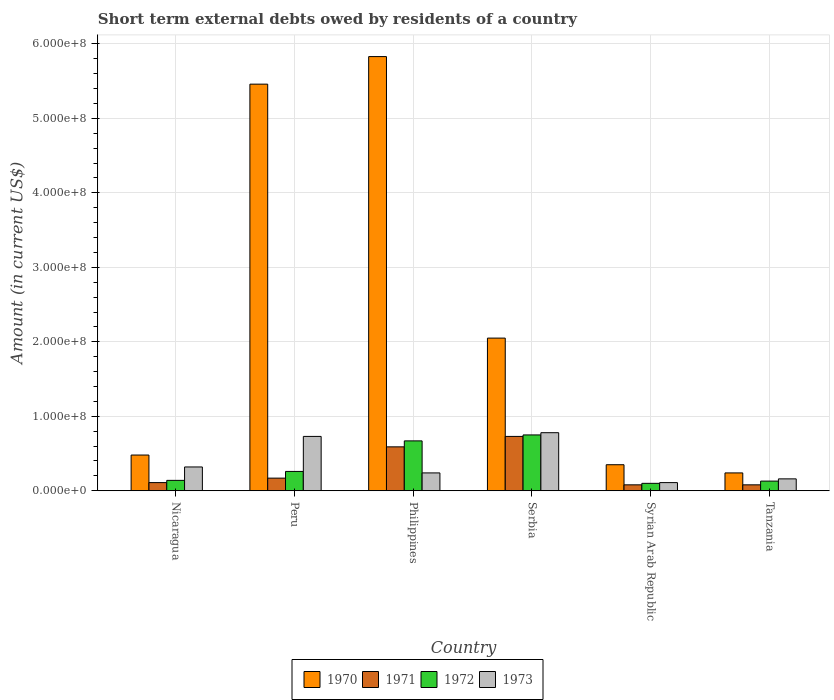How many different coloured bars are there?
Make the answer very short. 4. Are the number of bars on each tick of the X-axis equal?
Make the answer very short. Yes. How many bars are there on the 6th tick from the left?
Offer a terse response. 4. How many bars are there on the 5th tick from the right?
Provide a short and direct response. 4. What is the amount of short-term external debts owed by residents in 1972 in Serbia?
Your answer should be very brief. 7.50e+07. Across all countries, what is the maximum amount of short-term external debts owed by residents in 1971?
Make the answer very short. 7.30e+07. Across all countries, what is the minimum amount of short-term external debts owed by residents in 1972?
Give a very brief answer. 1.00e+07. In which country was the amount of short-term external debts owed by residents in 1973 maximum?
Ensure brevity in your answer.  Serbia. In which country was the amount of short-term external debts owed by residents in 1972 minimum?
Make the answer very short. Syrian Arab Republic. What is the total amount of short-term external debts owed by residents in 1971 in the graph?
Your answer should be compact. 1.76e+08. What is the difference between the amount of short-term external debts owed by residents in 1971 in Peru and that in Philippines?
Provide a succinct answer. -4.20e+07. What is the difference between the amount of short-term external debts owed by residents in 1970 in Peru and the amount of short-term external debts owed by residents in 1971 in Nicaragua?
Your answer should be very brief. 5.35e+08. What is the average amount of short-term external debts owed by residents in 1972 per country?
Make the answer very short. 3.42e+07. What is the difference between the amount of short-term external debts owed by residents of/in 1973 and amount of short-term external debts owed by residents of/in 1970 in Tanzania?
Keep it short and to the point. -8.00e+06. In how many countries, is the amount of short-term external debts owed by residents in 1970 greater than 400000000 US$?
Your answer should be compact. 2. What is the ratio of the amount of short-term external debts owed by residents in 1970 in Nicaragua to that in Philippines?
Give a very brief answer. 0.08. Is the amount of short-term external debts owed by residents in 1973 in Peru less than that in Syrian Arab Republic?
Provide a short and direct response. No. What is the difference between the highest and the second highest amount of short-term external debts owed by residents in 1971?
Provide a short and direct response. 5.60e+07. What is the difference between the highest and the lowest amount of short-term external debts owed by residents in 1972?
Your response must be concise. 6.50e+07. In how many countries, is the amount of short-term external debts owed by residents in 1972 greater than the average amount of short-term external debts owed by residents in 1972 taken over all countries?
Offer a terse response. 2. Is it the case that in every country, the sum of the amount of short-term external debts owed by residents in 1971 and amount of short-term external debts owed by residents in 1972 is greater than the sum of amount of short-term external debts owed by residents in 1970 and amount of short-term external debts owed by residents in 1973?
Give a very brief answer. No. What does the 3rd bar from the right in Nicaragua represents?
Ensure brevity in your answer.  1971. Is it the case that in every country, the sum of the amount of short-term external debts owed by residents in 1970 and amount of short-term external debts owed by residents in 1971 is greater than the amount of short-term external debts owed by residents in 1973?
Your answer should be very brief. Yes. How many bars are there?
Your response must be concise. 24. How many countries are there in the graph?
Provide a short and direct response. 6. Are the values on the major ticks of Y-axis written in scientific E-notation?
Your response must be concise. Yes. Does the graph contain any zero values?
Give a very brief answer. No. Does the graph contain grids?
Your response must be concise. Yes. Where does the legend appear in the graph?
Keep it short and to the point. Bottom center. How many legend labels are there?
Keep it short and to the point. 4. How are the legend labels stacked?
Provide a succinct answer. Horizontal. What is the title of the graph?
Your answer should be compact. Short term external debts owed by residents of a country. What is the label or title of the X-axis?
Ensure brevity in your answer.  Country. What is the label or title of the Y-axis?
Keep it short and to the point. Amount (in current US$). What is the Amount (in current US$) of 1970 in Nicaragua?
Keep it short and to the point. 4.80e+07. What is the Amount (in current US$) in 1971 in Nicaragua?
Give a very brief answer. 1.10e+07. What is the Amount (in current US$) in 1972 in Nicaragua?
Your answer should be very brief. 1.40e+07. What is the Amount (in current US$) of 1973 in Nicaragua?
Your answer should be compact. 3.20e+07. What is the Amount (in current US$) in 1970 in Peru?
Ensure brevity in your answer.  5.46e+08. What is the Amount (in current US$) in 1971 in Peru?
Give a very brief answer. 1.70e+07. What is the Amount (in current US$) in 1972 in Peru?
Your answer should be compact. 2.60e+07. What is the Amount (in current US$) of 1973 in Peru?
Offer a very short reply. 7.30e+07. What is the Amount (in current US$) in 1970 in Philippines?
Provide a succinct answer. 5.83e+08. What is the Amount (in current US$) in 1971 in Philippines?
Your answer should be very brief. 5.90e+07. What is the Amount (in current US$) of 1972 in Philippines?
Your answer should be compact. 6.70e+07. What is the Amount (in current US$) of 1973 in Philippines?
Ensure brevity in your answer.  2.40e+07. What is the Amount (in current US$) in 1970 in Serbia?
Provide a succinct answer. 2.05e+08. What is the Amount (in current US$) in 1971 in Serbia?
Your answer should be compact. 7.30e+07. What is the Amount (in current US$) in 1972 in Serbia?
Provide a succinct answer. 7.50e+07. What is the Amount (in current US$) of 1973 in Serbia?
Your response must be concise. 7.80e+07. What is the Amount (in current US$) of 1970 in Syrian Arab Republic?
Ensure brevity in your answer.  3.50e+07. What is the Amount (in current US$) in 1973 in Syrian Arab Republic?
Your answer should be compact. 1.10e+07. What is the Amount (in current US$) in 1970 in Tanzania?
Provide a short and direct response. 2.40e+07. What is the Amount (in current US$) in 1972 in Tanzania?
Your answer should be compact. 1.30e+07. What is the Amount (in current US$) in 1973 in Tanzania?
Offer a very short reply. 1.60e+07. Across all countries, what is the maximum Amount (in current US$) in 1970?
Offer a terse response. 5.83e+08. Across all countries, what is the maximum Amount (in current US$) of 1971?
Keep it short and to the point. 7.30e+07. Across all countries, what is the maximum Amount (in current US$) in 1972?
Your answer should be compact. 7.50e+07. Across all countries, what is the maximum Amount (in current US$) of 1973?
Provide a short and direct response. 7.80e+07. Across all countries, what is the minimum Amount (in current US$) of 1970?
Your answer should be very brief. 2.40e+07. Across all countries, what is the minimum Amount (in current US$) in 1973?
Keep it short and to the point. 1.10e+07. What is the total Amount (in current US$) in 1970 in the graph?
Offer a very short reply. 1.44e+09. What is the total Amount (in current US$) in 1971 in the graph?
Make the answer very short. 1.76e+08. What is the total Amount (in current US$) in 1972 in the graph?
Offer a very short reply. 2.05e+08. What is the total Amount (in current US$) in 1973 in the graph?
Your answer should be compact. 2.34e+08. What is the difference between the Amount (in current US$) of 1970 in Nicaragua and that in Peru?
Offer a very short reply. -4.98e+08. What is the difference between the Amount (in current US$) in 1971 in Nicaragua and that in Peru?
Ensure brevity in your answer.  -6.00e+06. What is the difference between the Amount (in current US$) of 1972 in Nicaragua and that in Peru?
Your answer should be compact. -1.20e+07. What is the difference between the Amount (in current US$) of 1973 in Nicaragua and that in Peru?
Offer a very short reply. -4.10e+07. What is the difference between the Amount (in current US$) in 1970 in Nicaragua and that in Philippines?
Your answer should be compact. -5.35e+08. What is the difference between the Amount (in current US$) of 1971 in Nicaragua and that in Philippines?
Your response must be concise. -4.80e+07. What is the difference between the Amount (in current US$) of 1972 in Nicaragua and that in Philippines?
Provide a short and direct response. -5.30e+07. What is the difference between the Amount (in current US$) in 1970 in Nicaragua and that in Serbia?
Ensure brevity in your answer.  -1.57e+08. What is the difference between the Amount (in current US$) of 1971 in Nicaragua and that in Serbia?
Offer a terse response. -6.20e+07. What is the difference between the Amount (in current US$) of 1972 in Nicaragua and that in Serbia?
Offer a very short reply. -6.10e+07. What is the difference between the Amount (in current US$) in 1973 in Nicaragua and that in Serbia?
Your answer should be very brief. -4.60e+07. What is the difference between the Amount (in current US$) in 1970 in Nicaragua and that in Syrian Arab Republic?
Offer a terse response. 1.30e+07. What is the difference between the Amount (in current US$) of 1971 in Nicaragua and that in Syrian Arab Republic?
Keep it short and to the point. 3.00e+06. What is the difference between the Amount (in current US$) of 1972 in Nicaragua and that in Syrian Arab Republic?
Ensure brevity in your answer.  4.00e+06. What is the difference between the Amount (in current US$) in 1973 in Nicaragua and that in Syrian Arab Republic?
Offer a terse response. 2.10e+07. What is the difference between the Amount (in current US$) of 1970 in Nicaragua and that in Tanzania?
Offer a very short reply. 2.40e+07. What is the difference between the Amount (in current US$) of 1971 in Nicaragua and that in Tanzania?
Offer a terse response. 3.00e+06. What is the difference between the Amount (in current US$) in 1973 in Nicaragua and that in Tanzania?
Your answer should be compact. 1.60e+07. What is the difference between the Amount (in current US$) in 1970 in Peru and that in Philippines?
Ensure brevity in your answer.  -3.70e+07. What is the difference between the Amount (in current US$) of 1971 in Peru and that in Philippines?
Make the answer very short. -4.20e+07. What is the difference between the Amount (in current US$) of 1972 in Peru and that in Philippines?
Make the answer very short. -4.10e+07. What is the difference between the Amount (in current US$) in 1973 in Peru and that in Philippines?
Make the answer very short. 4.90e+07. What is the difference between the Amount (in current US$) of 1970 in Peru and that in Serbia?
Offer a terse response. 3.41e+08. What is the difference between the Amount (in current US$) in 1971 in Peru and that in Serbia?
Ensure brevity in your answer.  -5.60e+07. What is the difference between the Amount (in current US$) in 1972 in Peru and that in Serbia?
Provide a short and direct response. -4.90e+07. What is the difference between the Amount (in current US$) in 1973 in Peru and that in Serbia?
Your answer should be compact. -5.00e+06. What is the difference between the Amount (in current US$) of 1970 in Peru and that in Syrian Arab Republic?
Offer a very short reply. 5.11e+08. What is the difference between the Amount (in current US$) of 1971 in Peru and that in Syrian Arab Republic?
Provide a succinct answer. 9.00e+06. What is the difference between the Amount (in current US$) in 1972 in Peru and that in Syrian Arab Republic?
Ensure brevity in your answer.  1.60e+07. What is the difference between the Amount (in current US$) in 1973 in Peru and that in Syrian Arab Republic?
Your response must be concise. 6.20e+07. What is the difference between the Amount (in current US$) in 1970 in Peru and that in Tanzania?
Make the answer very short. 5.22e+08. What is the difference between the Amount (in current US$) of 1971 in Peru and that in Tanzania?
Your answer should be compact. 9.00e+06. What is the difference between the Amount (in current US$) in 1972 in Peru and that in Tanzania?
Offer a terse response. 1.30e+07. What is the difference between the Amount (in current US$) in 1973 in Peru and that in Tanzania?
Ensure brevity in your answer.  5.70e+07. What is the difference between the Amount (in current US$) of 1970 in Philippines and that in Serbia?
Offer a terse response. 3.78e+08. What is the difference between the Amount (in current US$) of 1971 in Philippines and that in Serbia?
Offer a very short reply. -1.40e+07. What is the difference between the Amount (in current US$) of 1972 in Philippines and that in Serbia?
Offer a very short reply. -8.00e+06. What is the difference between the Amount (in current US$) of 1973 in Philippines and that in Serbia?
Your answer should be compact. -5.40e+07. What is the difference between the Amount (in current US$) of 1970 in Philippines and that in Syrian Arab Republic?
Provide a short and direct response. 5.48e+08. What is the difference between the Amount (in current US$) of 1971 in Philippines and that in Syrian Arab Republic?
Make the answer very short. 5.10e+07. What is the difference between the Amount (in current US$) of 1972 in Philippines and that in Syrian Arab Republic?
Your answer should be very brief. 5.70e+07. What is the difference between the Amount (in current US$) of 1973 in Philippines and that in Syrian Arab Republic?
Give a very brief answer. 1.30e+07. What is the difference between the Amount (in current US$) of 1970 in Philippines and that in Tanzania?
Your answer should be compact. 5.59e+08. What is the difference between the Amount (in current US$) in 1971 in Philippines and that in Tanzania?
Your response must be concise. 5.10e+07. What is the difference between the Amount (in current US$) in 1972 in Philippines and that in Tanzania?
Offer a very short reply. 5.40e+07. What is the difference between the Amount (in current US$) of 1970 in Serbia and that in Syrian Arab Republic?
Your answer should be very brief. 1.70e+08. What is the difference between the Amount (in current US$) in 1971 in Serbia and that in Syrian Arab Republic?
Keep it short and to the point. 6.50e+07. What is the difference between the Amount (in current US$) in 1972 in Serbia and that in Syrian Arab Republic?
Keep it short and to the point. 6.50e+07. What is the difference between the Amount (in current US$) in 1973 in Serbia and that in Syrian Arab Republic?
Provide a short and direct response. 6.70e+07. What is the difference between the Amount (in current US$) in 1970 in Serbia and that in Tanzania?
Keep it short and to the point. 1.81e+08. What is the difference between the Amount (in current US$) in 1971 in Serbia and that in Tanzania?
Your response must be concise. 6.50e+07. What is the difference between the Amount (in current US$) of 1972 in Serbia and that in Tanzania?
Provide a succinct answer. 6.20e+07. What is the difference between the Amount (in current US$) in 1973 in Serbia and that in Tanzania?
Give a very brief answer. 6.20e+07. What is the difference between the Amount (in current US$) of 1970 in Syrian Arab Republic and that in Tanzania?
Your answer should be very brief. 1.10e+07. What is the difference between the Amount (in current US$) in 1972 in Syrian Arab Republic and that in Tanzania?
Your response must be concise. -3.00e+06. What is the difference between the Amount (in current US$) in 1973 in Syrian Arab Republic and that in Tanzania?
Provide a short and direct response. -5.00e+06. What is the difference between the Amount (in current US$) of 1970 in Nicaragua and the Amount (in current US$) of 1971 in Peru?
Provide a short and direct response. 3.10e+07. What is the difference between the Amount (in current US$) in 1970 in Nicaragua and the Amount (in current US$) in 1972 in Peru?
Offer a terse response. 2.20e+07. What is the difference between the Amount (in current US$) in 1970 in Nicaragua and the Amount (in current US$) in 1973 in Peru?
Your answer should be compact. -2.50e+07. What is the difference between the Amount (in current US$) of 1971 in Nicaragua and the Amount (in current US$) of 1972 in Peru?
Offer a very short reply. -1.50e+07. What is the difference between the Amount (in current US$) in 1971 in Nicaragua and the Amount (in current US$) in 1973 in Peru?
Provide a succinct answer. -6.20e+07. What is the difference between the Amount (in current US$) in 1972 in Nicaragua and the Amount (in current US$) in 1973 in Peru?
Your answer should be compact. -5.90e+07. What is the difference between the Amount (in current US$) in 1970 in Nicaragua and the Amount (in current US$) in 1971 in Philippines?
Keep it short and to the point. -1.10e+07. What is the difference between the Amount (in current US$) in 1970 in Nicaragua and the Amount (in current US$) in 1972 in Philippines?
Your answer should be very brief. -1.90e+07. What is the difference between the Amount (in current US$) in 1970 in Nicaragua and the Amount (in current US$) in 1973 in Philippines?
Your answer should be very brief. 2.40e+07. What is the difference between the Amount (in current US$) of 1971 in Nicaragua and the Amount (in current US$) of 1972 in Philippines?
Your answer should be very brief. -5.60e+07. What is the difference between the Amount (in current US$) in 1971 in Nicaragua and the Amount (in current US$) in 1973 in Philippines?
Give a very brief answer. -1.30e+07. What is the difference between the Amount (in current US$) in 1972 in Nicaragua and the Amount (in current US$) in 1973 in Philippines?
Your answer should be compact. -1.00e+07. What is the difference between the Amount (in current US$) of 1970 in Nicaragua and the Amount (in current US$) of 1971 in Serbia?
Give a very brief answer. -2.50e+07. What is the difference between the Amount (in current US$) in 1970 in Nicaragua and the Amount (in current US$) in 1972 in Serbia?
Your answer should be compact. -2.70e+07. What is the difference between the Amount (in current US$) in 1970 in Nicaragua and the Amount (in current US$) in 1973 in Serbia?
Your answer should be very brief. -3.00e+07. What is the difference between the Amount (in current US$) of 1971 in Nicaragua and the Amount (in current US$) of 1972 in Serbia?
Offer a terse response. -6.40e+07. What is the difference between the Amount (in current US$) in 1971 in Nicaragua and the Amount (in current US$) in 1973 in Serbia?
Your answer should be compact. -6.70e+07. What is the difference between the Amount (in current US$) in 1972 in Nicaragua and the Amount (in current US$) in 1973 in Serbia?
Your response must be concise. -6.40e+07. What is the difference between the Amount (in current US$) of 1970 in Nicaragua and the Amount (in current US$) of 1971 in Syrian Arab Republic?
Your response must be concise. 4.00e+07. What is the difference between the Amount (in current US$) in 1970 in Nicaragua and the Amount (in current US$) in 1972 in Syrian Arab Republic?
Provide a short and direct response. 3.80e+07. What is the difference between the Amount (in current US$) in 1970 in Nicaragua and the Amount (in current US$) in 1973 in Syrian Arab Republic?
Provide a short and direct response. 3.70e+07. What is the difference between the Amount (in current US$) of 1972 in Nicaragua and the Amount (in current US$) of 1973 in Syrian Arab Republic?
Your answer should be compact. 3.00e+06. What is the difference between the Amount (in current US$) in 1970 in Nicaragua and the Amount (in current US$) in 1971 in Tanzania?
Make the answer very short. 4.00e+07. What is the difference between the Amount (in current US$) in 1970 in Nicaragua and the Amount (in current US$) in 1972 in Tanzania?
Your response must be concise. 3.50e+07. What is the difference between the Amount (in current US$) in 1970 in Nicaragua and the Amount (in current US$) in 1973 in Tanzania?
Offer a very short reply. 3.20e+07. What is the difference between the Amount (in current US$) of 1971 in Nicaragua and the Amount (in current US$) of 1973 in Tanzania?
Provide a succinct answer. -5.00e+06. What is the difference between the Amount (in current US$) of 1970 in Peru and the Amount (in current US$) of 1971 in Philippines?
Your answer should be compact. 4.87e+08. What is the difference between the Amount (in current US$) of 1970 in Peru and the Amount (in current US$) of 1972 in Philippines?
Keep it short and to the point. 4.79e+08. What is the difference between the Amount (in current US$) in 1970 in Peru and the Amount (in current US$) in 1973 in Philippines?
Ensure brevity in your answer.  5.22e+08. What is the difference between the Amount (in current US$) in 1971 in Peru and the Amount (in current US$) in 1972 in Philippines?
Provide a short and direct response. -5.00e+07. What is the difference between the Amount (in current US$) of 1971 in Peru and the Amount (in current US$) of 1973 in Philippines?
Offer a terse response. -7.00e+06. What is the difference between the Amount (in current US$) in 1972 in Peru and the Amount (in current US$) in 1973 in Philippines?
Ensure brevity in your answer.  2.00e+06. What is the difference between the Amount (in current US$) of 1970 in Peru and the Amount (in current US$) of 1971 in Serbia?
Provide a succinct answer. 4.73e+08. What is the difference between the Amount (in current US$) of 1970 in Peru and the Amount (in current US$) of 1972 in Serbia?
Provide a short and direct response. 4.71e+08. What is the difference between the Amount (in current US$) in 1970 in Peru and the Amount (in current US$) in 1973 in Serbia?
Ensure brevity in your answer.  4.68e+08. What is the difference between the Amount (in current US$) of 1971 in Peru and the Amount (in current US$) of 1972 in Serbia?
Ensure brevity in your answer.  -5.80e+07. What is the difference between the Amount (in current US$) of 1971 in Peru and the Amount (in current US$) of 1973 in Serbia?
Give a very brief answer. -6.10e+07. What is the difference between the Amount (in current US$) of 1972 in Peru and the Amount (in current US$) of 1973 in Serbia?
Your response must be concise. -5.20e+07. What is the difference between the Amount (in current US$) of 1970 in Peru and the Amount (in current US$) of 1971 in Syrian Arab Republic?
Your answer should be very brief. 5.38e+08. What is the difference between the Amount (in current US$) in 1970 in Peru and the Amount (in current US$) in 1972 in Syrian Arab Republic?
Ensure brevity in your answer.  5.36e+08. What is the difference between the Amount (in current US$) of 1970 in Peru and the Amount (in current US$) of 1973 in Syrian Arab Republic?
Give a very brief answer. 5.35e+08. What is the difference between the Amount (in current US$) in 1971 in Peru and the Amount (in current US$) in 1973 in Syrian Arab Republic?
Provide a succinct answer. 6.00e+06. What is the difference between the Amount (in current US$) of 1972 in Peru and the Amount (in current US$) of 1973 in Syrian Arab Republic?
Your answer should be compact. 1.50e+07. What is the difference between the Amount (in current US$) of 1970 in Peru and the Amount (in current US$) of 1971 in Tanzania?
Offer a very short reply. 5.38e+08. What is the difference between the Amount (in current US$) of 1970 in Peru and the Amount (in current US$) of 1972 in Tanzania?
Your answer should be very brief. 5.33e+08. What is the difference between the Amount (in current US$) in 1970 in Peru and the Amount (in current US$) in 1973 in Tanzania?
Your answer should be compact. 5.30e+08. What is the difference between the Amount (in current US$) of 1971 in Peru and the Amount (in current US$) of 1972 in Tanzania?
Your response must be concise. 4.00e+06. What is the difference between the Amount (in current US$) in 1971 in Peru and the Amount (in current US$) in 1973 in Tanzania?
Offer a terse response. 1.00e+06. What is the difference between the Amount (in current US$) in 1972 in Peru and the Amount (in current US$) in 1973 in Tanzania?
Offer a very short reply. 1.00e+07. What is the difference between the Amount (in current US$) of 1970 in Philippines and the Amount (in current US$) of 1971 in Serbia?
Ensure brevity in your answer.  5.10e+08. What is the difference between the Amount (in current US$) in 1970 in Philippines and the Amount (in current US$) in 1972 in Serbia?
Your response must be concise. 5.08e+08. What is the difference between the Amount (in current US$) of 1970 in Philippines and the Amount (in current US$) of 1973 in Serbia?
Your response must be concise. 5.05e+08. What is the difference between the Amount (in current US$) of 1971 in Philippines and the Amount (in current US$) of 1972 in Serbia?
Your response must be concise. -1.60e+07. What is the difference between the Amount (in current US$) of 1971 in Philippines and the Amount (in current US$) of 1973 in Serbia?
Make the answer very short. -1.90e+07. What is the difference between the Amount (in current US$) of 1972 in Philippines and the Amount (in current US$) of 1973 in Serbia?
Provide a short and direct response. -1.10e+07. What is the difference between the Amount (in current US$) in 1970 in Philippines and the Amount (in current US$) in 1971 in Syrian Arab Republic?
Ensure brevity in your answer.  5.75e+08. What is the difference between the Amount (in current US$) in 1970 in Philippines and the Amount (in current US$) in 1972 in Syrian Arab Republic?
Provide a short and direct response. 5.73e+08. What is the difference between the Amount (in current US$) of 1970 in Philippines and the Amount (in current US$) of 1973 in Syrian Arab Republic?
Ensure brevity in your answer.  5.72e+08. What is the difference between the Amount (in current US$) in 1971 in Philippines and the Amount (in current US$) in 1972 in Syrian Arab Republic?
Ensure brevity in your answer.  4.90e+07. What is the difference between the Amount (in current US$) in 1971 in Philippines and the Amount (in current US$) in 1973 in Syrian Arab Republic?
Ensure brevity in your answer.  4.80e+07. What is the difference between the Amount (in current US$) of 1972 in Philippines and the Amount (in current US$) of 1973 in Syrian Arab Republic?
Ensure brevity in your answer.  5.60e+07. What is the difference between the Amount (in current US$) of 1970 in Philippines and the Amount (in current US$) of 1971 in Tanzania?
Make the answer very short. 5.75e+08. What is the difference between the Amount (in current US$) in 1970 in Philippines and the Amount (in current US$) in 1972 in Tanzania?
Ensure brevity in your answer.  5.70e+08. What is the difference between the Amount (in current US$) of 1970 in Philippines and the Amount (in current US$) of 1973 in Tanzania?
Offer a terse response. 5.67e+08. What is the difference between the Amount (in current US$) of 1971 in Philippines and the Amount (in current US$) of 1972 in Tanzania?
Your answer should be very brief. 4.60e+07. What is the difference between the Amount (in current US$) in 1971 in Philippines and the Amount (in current US$) in 1973 in Tanzania?
Offer a terse response. 4.30e+07. What is the difference between the Amount (in current US$) of 1972 in Philippines and the Amount (in current US$) of 1973 in Tanzania?
Your answer should be compact. 5.10e+07. What is the difference between the Amount (in current US$) in 1970 in Serbia and the Amount (in current US$) in 1971 in Syrian Arab Republic?
Offer a very short reply. 1.97e+08. What is the difference between the Amount (in current US$) in 1970 in Serbia and the Amount (in current US$) in 1972 in Syrian Arab Republic?
Make the answer very short. 1.95e+08. What is the difference between the Amount (in current US$) in 1970 in Serbia and the Amount (in current US$) in 1973 in Syrian Arab Republic?
Ensure brevity in your answer.  1.94e+08. What is the difference between the Amount (in current US$) in 1971 in Serbia and the Amount (in current US$) in 1972 in Syrian Arab Republic?
Your answer should be compact. 6.30e+07. What is the difference between the Amount (in current US$) of 1971 in Serbia and the Amount (in current US$) of 1973 in Syrian Arab Republic?
Give a very brief answer. 6.20e+07. What is the difference between the Amount (in current US$) in 1972 in Serbia and the Amount (in current US$) in 1973 in Syrian Arab Republic?
Offer a very short reply. 6.40e+07. What is the difference between the Amount (in current US$) of 1970 in Serbia and the Amount (in current US$) of 1971 in Tanzania?
Provide a succinct answer. 1.97e+08. What is the difference between the Amount (in current US$) of 1970 in Serbia and the Amount (in current US$) of 1972 in Tanzania?
Make the answer very short. 1.92e+08. What is the difference between the Amount (in current US$) of 1970 in Serbia and the Amount (in current US$) of 1973 in Tanzania?
Make the answer very short. 1.89e+08. What is the difference between the Amount (in current US$) of 1971 in Serbia and the Amount (in current US$) of 1972 in Tanzania?
Provide a short and direct response. 6.00e+07. What is the difference between the Amount (in current US$) in 1971 in Serbia and the Amount (in current US$) in 1973 in Tanzania?
Give a very brief answer. 5.70e+07. What is the difference between the Amount (in current US$) in 1972 in Serbia and the Amount (in current US$) in 1973 in Tanzania?
Provide a succinct answer. 5.90e+07. What is the difference between the Amount (in current US$) of 1970 in Syrian Arab Republic and the Amount (in current US$) of 1971 in Tanzania?
Make the answer very short. 2.70e+07. What is the difference between the Amount (in current US$) of 1970 in Syrian Arab Republic and the Amount (in current US$) of 1972 in Tanzania?
Offer a terse response. 2.20e+07. What is the difference between the Amount (in current US$) in 1970 in Syrian Arab Republic and the Amount (in current US$) in 1973 in Tanzania?
Ensure brevity in your answer.  1.90e+07. What is the difference between the Amount (in current US$) in 1971 in Syrian Arab Republic and the Amount (in current US$) in 1972 in Tanzania?
Offer a terse response. -5.00e+06. What is the difference between the Amount (in current US$) of 1971 in Syrian Arab Republic and the Amount (in current US$) of 1973 in Tanzania?
Give a very brief answer. -8.00e+06. What is the difference between the Amount (in current US$) in 1972 in Syrian Arab Republic and the Amount (in current US$) in 1973 in Tanzania?
Your answer should be compact. -6.00e+06. What is the average Amount (in current US$) in 1970 per country?
Make the answer very short. 2.40e+08. What is the average Amount (in current US$) in 1971 per country?
Your answer should be very brief. 2.93e+07. What is the average Amount (in current US$) in 1972 per country?
Keep it short and to the point. 3.42e+07. What is the average Amount (in current US$) in 1973 per country?
Ensure brevity in your answer.  3.90e+07. What is the difference between the Amount (in current US$) in 1970 and Amount (in current US$) in 1971 in Nicaragua?
Your answer should be compact. 3.70e+07. What is the difference between the Amount (in current US$) in 1970 and Amount (in current US$) in 1972 in Nicaragua?
Provide a succinct answer. 3.40e+07. What is the difference between the Amount (in current US$) of 1970 and Amount (in current US$) of 1973 in Nicaragua?
Your answer should be compact. 1.60e+07. What is the difference between the Amount (in current US$) in 1971 and Amount (in current US$) in 1972 in Nicaragua?
Offer a terse response. -3.00e+06. What is the difference between the Amount (in current US$) of 1971 and Amount (in current US$) of 1973 in Nicaragua?
Provide a succinct answer. -2.10e+07. What is the difference between the Amount (in current US$) in 1972 and Amount (in current US$) in 1973 in Nicaragua?
Offer a very short reply. -1.80e+07. What is the difference between the Amount (in current US$) in 1970 and Amount (in current US$) in 1971 in Peru?
Offer a terse response. 5.29e+08. What is the difference between the Amount (in current US$) in 1970 and Amount (in current US$) in 1972 in Peru?
Your answer should be very brief. 5.20e+08. What is the difference between the Amount (in current US$) in 1970 and Amount (in current US$) in 1973 in Peru?
Provide a short and direct response. 4.73e+08. What is the difference between the Amount (in current US$) in 1971 and Amount (in current US$) in 1972 in Peru?
Your response must be concise. -9.00e+06. What is the difference between the Amount (in current US$) in 1971 and Amount (in current US$) in 1973 in Peru?
Provide a succinct answer. -5.60e+07. What is the difference between the Amount (in current US$) of 1972 and Amount (in current US$) of 1973 in Peru?
Make the answer very short. -4.70e+07. What is the difference between the Amount (in current US$) in 1970 and Amount (in current US$) in 1971 in Philippines?
Give a very brief answer. 5.24e+08. What is the difference between the Amount (in current US$) in 1970 and Amount (in current US$) in 1972 in Philippines?
Give a very brief answer. 5.16e+08. What is the difference between the Amount (in current US$) in 1970 and Amount (in current US$) in 1973 in Philippines?
Make the answer very short. 5.59e+08. What is the difference between the Amount (in current US$) in 1971 and Amount (in current US$) in 1972 in Philippines?
Provide a short and direct response. -8.00e+06. What is the difference between the Amount (in current US$) of 1971 and Amount (in current US$) of 1973 in Philippines?
Provide a succinct answer. 3.50e+07. What is the difference between the Amount (in current US$) in 1972 and Amount (in current US$) in 1973 in Philippines?
Your answer should be very brief. 4.30e+07. What is the difference between the Amount (in current US$) of 1970 and Amount (in current US$) of 1971 in Serbia?
Ensure brevity in your answer.  1.32e+08. What is the difference between the Amount (in current US$) of 1970 and Amount (in current US$) of 1972 in Serbia?
Provide a short and direct response. 1.30e+08. What is the difference between the Amount (in current US$) of 1970 and Amount (in current US$) of 1973 in Serbia?
Your answer should be very brief. 1.27e+08. What is the difference between the Amount (in current US$) in 1971 and Amount (in current US$) in 1973 in Serbia?
Your answer should be very brief. -5.00e+06. What is the difference between the Amount (in current US$) of 1970 and Amount (in current US$) of 1971 in Syrian Arab Republic?
Keep it short and to the point. 2.70e+07. What is the difference between the Amount (in current US$) of 1970 and Amount (in current US$) of 1972 in Syrian Arab Republic?
Make the answer very short. 2.50e+07. What is the difference between the Amount (in current US$) in 1970 and Amount (in current US$) in 1973 in Syrian Arab Republic?
Your response must be concise. 2.40e+07. What is the difference between the Amount (in current US$) in 1971 and Amount (in current US$) in 1972 in Syrian Arab Republic?
Your answer should be compact. -2.00e+06. What is the difference between the Amount (in current US$) of 1971 and Amount (in current US$) of 1973 in Syrian Arab Republic?
Provide a succinct answer. -3.00e+06. What is the difference between the Amount (in current US$) of 1972 and Amount (in current US$) of 1973 in Syrian Arab Republic?
Offer a terse response. -1.00e+06. What is the difference between the Amount (in current US$) of 1970 and Amount (in current US$) of 1971 in Tanzania?
Offer a very short reply. 1.60e+07. What is the difference between the Amount (in current US$) of 1970 and Amount (in current US$) of 1972 in Tanzania?
Your answer should be very brief. 1.10e+07. What is the difference between the Amount (in current US$) of 1971 and Amount (in current US$) of 1972 in Tanzania?
Offer a terse response. -5.00e+06. What is the difference between the Amount (in current US$) of 1971 and Amount (in current US$) of 1973 in Tanzania?
Offer a very short reply. -8.00e+06. What is the difference between the Amount (in current US$) in 1972 and Amount (in current US$) in 1973 in Tanzania?
Give a very brief answer. -3.00e+06. What is the ratio of the Amount (in current US$) of 1970 in Nicaragua to that in Peru?
Offer a terse response. 0.09. What is the ratio of the Amount (in current US$) of 1971 in Nicaragua to that in Peru?
Ensure brevity in your answer.  0.65. What is the ratio of the Amount (in current US$) in 1972 in Nicaragua to that in Peru?
Make the answer very short. 0.54. What is the ratio of the Amount (in current US$) of 1973 in Nicaragua to that in Peru?
Your answer should be very brief. 0.44. What is the ratio of the Amount (in current US$) in 1970 in Nicaragua to that in Philippines?
Offer a very short reply. 0.08. What is the ratio of the Amount (in current US$) of 1971 in Nicaragua to that in Philippines?
Your answer should be compact. 0.19. What is the ratio of the Amount (in current US$) of 1972 in Nicaragua to that in Philippines?
Ensure brevity in your answer.  0.21. What is the ratio of the Amount (in current US$) in 1973 in Nicaragua to that in Philippines?
Provide a short and direct response. 1.33. What is the ratio of the Amount (in current US$) in 1970 in Nicaragua to that in Serbia?
Provide a succinct answer. 0.23. What is the ratio of the Amount (in current US$) in 1971 in Nicaragua to that in Serbia?
Provide a succinct answer. 0.15. What is the ratio of the Amount (in current US$) of 1972 in Nicaragua to that in Serbia?
Keep it short and to the point. 0.19. What is the ratio of the Amount (in current US$) in 1973 in Nicaragua to that in Serbia?
Your answer should be very brief. 0.41. What is the ratio of the Amount (in current US$) of 1970 in Nicaragua to that in Syrian Arab Republic?
Your answer should be compact. 1.37. What is the ratio of the Amount (in current US$) of 1971 in Nicaragua to that in Syrian Arab Republic?
Give a very brief answer. 1.38. What is the ratio of the Amount (in current US$) in 1972 in Nicaragua to that in Syrian Arab Republic?
Make the answer very short. 1.4. What is the ratio of the Amount (in current US$) in 1973 in Nicaragua to that in Syrian Arab Republic?
Offer a terse response. 2.91. What is the ratio of the Amount (in current US$) of 1970 in Nicaragua to that in Tanzania?
Give a very brief answer. 2. What is the ratio of the Amount (in current US$) in 1971 in Nicaragua to that in Tanzania?
Offer a very short reply. 1.38. What is the ratio of the Amount (in current US$) of 1972 in Nicaragua to that in Tanzania?
Your answer should be very brief. 1.08. What is the ratio of the Amount (in current US$) of 1973 in Nicaragua to that in Tanzania?
Your response must be concise. 2. What is the ratio of the Amount (in current US$) of 1970 in Peru to that in Philippines?
Provide a short and direct response. 0.94. What is the ratio of the Amount (in current US$) of 1971 in Peru to that in Philippines?
Make the answer very short. 0.29. What is the ratio of the Amount (in current US$) of 1972 in Peru to that in Philippines?
Your response must be concise. 0.39. What is the ratio of the Amount (in current US$) in 1973 in Peru to that in Philippines?
Your response must be concise. 3.04. What is the ratio of the Amount (in current US$) of 1970 in Peru to that in Serbia?
Your answer should be compact. 2.66. What is the ratio of the Amount (in current US$) of 1971 in Peru to that in Serbia?
Keep it short and to the point. 0.23. What is the ratio of the Amount (in current US$) of 1972 in Peru to that in Serbia?
Make the answer very short. 0.35. What is the ratio of the Amount (in current US$) of 1973 in Peru to that in Serbia?
Your response must be concise. 0.94. What is the ratio of the Amount (in current US$) of 1970 in Peru to that in Syrian Arab Republic?
Make the answer very short. 15.6. What is the ratio of the Amount (in current US$) of 1971 in Peru to that in Syrian Arab Republic?
Your answer should be very brief. 2.12. What is the ratio of the Amount (in current US$) in 1973 in Peru to that in Syrian Arab Republic?
Make the answer very short. 6.64. What is the ratio of the Amount (in current US$) of 1970 in Peru to that in Tanzania?
Your response must be concise. 22.75. What is the ratio of the Amount (in current US$) of 1971 in Peru to that in Tanzania?
Your response must be concise. 2.12. What is the ratio of the Amount (in current US$) in 1973 in Peru to that in Tanzania?
Offer a terse response. 4.56. What is the ratio of the Amount (in current US$) in 1970 in Philippines to that in Serbia?
Offer a very short reply. 2.84. What is the ratio of the Amount (in current US$) of 1971 in Philippines to that in Serbia?
Your answer should be very brief. 0.81. What is the ratio of the Amount (in current US$) in 1972 in Philippines to that in Serbia?
Offer a terse response. 0.89. What is the ratio of the Amount (in current US$) in 1973 in Philippines to that in Serbia?
Give a very brief answer. 0.31. What is the ratio of the Amount (in current US$) of 1970 in Philippines to that in Syrian Arab Republic?
Provide a short and direct response. 16.66. What is the ratio of the Amount (in current US$) in 1971 in Philippines to that in Syrian Arab Republic?
Your response must be concise. 7.38. What is the ratio of the Amount (in current US$) of 1973 in Philippines to that in Syrian Arab Republic?
Make the answer very short. 2.18. What is the ratio of the Amount (in current US$) in 1970 in Philippines to that in Tanzania?
Your answer should be compact. 24.29. What is the ratio of the Amount (in current US$) in 1971 in Philippines to that in Tanzania?
Keep it short and to the point. 7.38. What is the ratio of the Amount (in current US$) in 1972 in Philippines to that in Tanzania?
Provide a short and direct response. 5.15. What is the ratio of the Amount (in current US$) of 1970 in Serbia to that in Syrian Arab Republic?
Provide a succinct answer. 5.86. What is the ratio of the Amount (in current US$) in 1971 in Serbia to that in Syrian Arab Republic?
Offer a terse response. 9.12. What is the ratio of the Amount (in current US$) in 1973 in Serbia to that in Syrian Arab Republic?
Provide a succinct answer. 7.09. What is the ratio of the Amount (in current US$) of 1970 in Serbia to that in Tanzania?
Give a very brief answer. 8.54. What is the ratio of the Amount (in current US$) in 1971 in Serbia to that in Tanzania?
Ensure brevity in your answer.  9.12. What is the ratio of the Amount (in current US$) in 1972 in Serbia to that in Tanzania?
Give a very brief answer. 5.77. What is the ratio of the Amount (in current US$) in 1973 in Serbia to that in Tanzania?
Offer a very short reply. 4.88. What is the ratio of the Amount (in current US$) of 1970 in Syrian Arab Republic to that in Tanzania?
Give a very brief answer. 1.46. What is the ratio of the Amount (in current US$) of 1972 in Syrian Arab Republic to that in Tanzania?
Ensure brevity in your answer.  0.77. What is the ratio of the Amount (in current US$) of 1973 in Syrian Arab Republic to that in Tanzania?
Your response must be concise. 0.69. What is the difference between the highest and the second highest Amount (in current US$) of 1970?
Ensure brevity in your answer.  3.70e+07. What is the difference between the highest and the second highest Amount (in current US$) in 1971?
Provide a short and direct response. 1.40e+07. What is the difference between the highest and the second highest Amount (in current US$) of 1973?
Keep it short and to the point. 5.00e+06. What is the difference between the highest and the lowest Amount (in current US$) in 1970?
Provide a succinct answer. 5.59e+08. What is the difference between the highest and the lowest Amount (in current US$) of 1971?
Your answer should be very brief. 6.50e+07. What is the difference between the highest and the lowest Amount (in current US$) in 1972?
Make the answer very short. 6.50e+07. What is the difference between the highest and the lowest Amount (in current US$) in 1973?
Ensure brevity in your answer.  6.70e+07. 